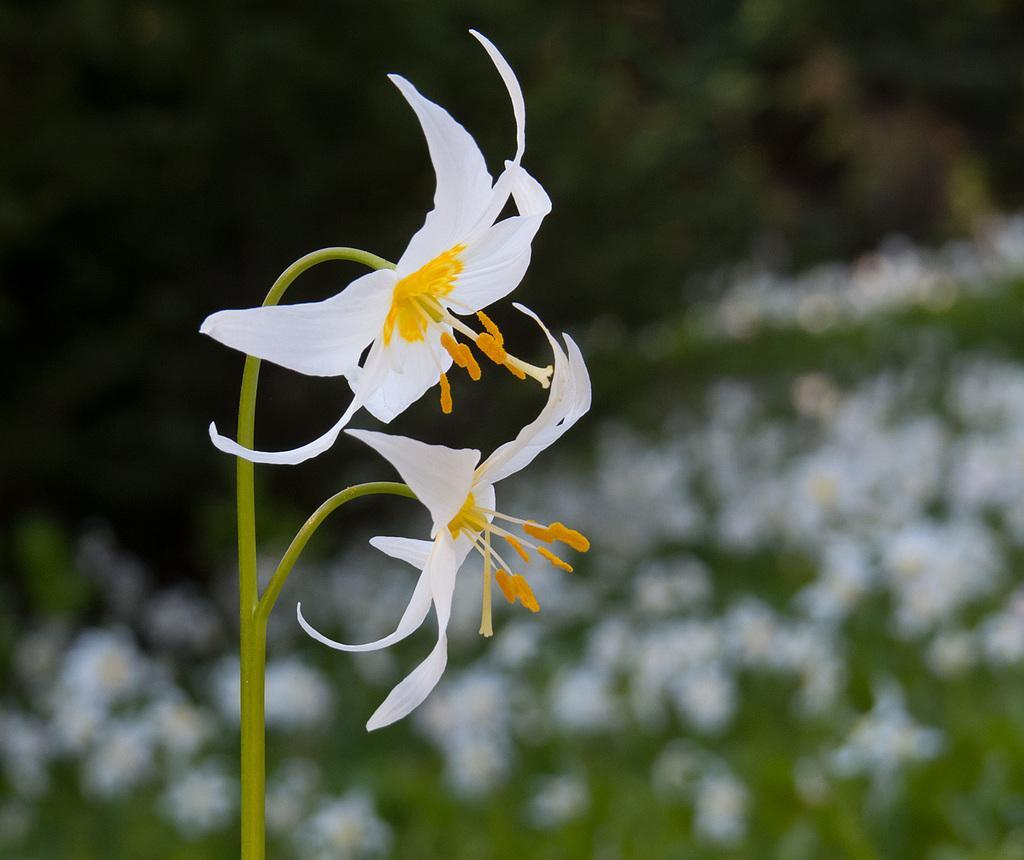Please provide a concise description of this image. In this picture there are flowers in the image, which are white in color. 